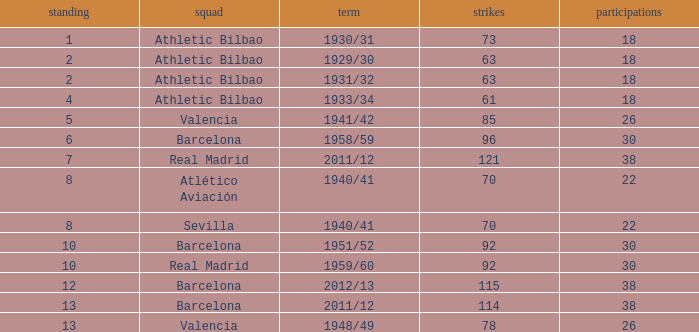How many apps when the rank was after 13 and having more than 73 goals? None. 